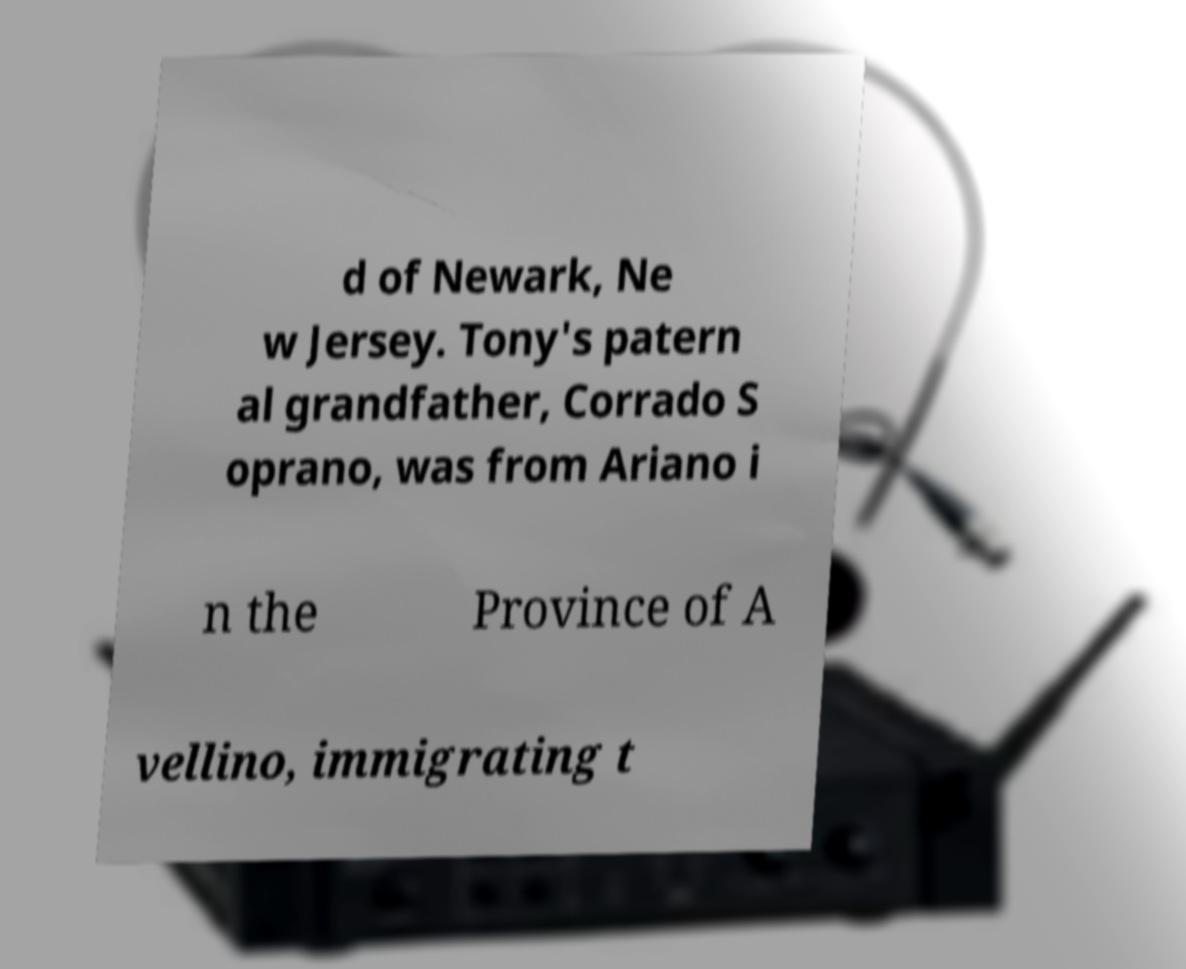Please identify and transcribe the text found in this image. d of Newark, Ne w Jersey. Tony's patern al grandfather, Corrado S oprano, was from Ariano i n the Province of A vellino, immigrating t 